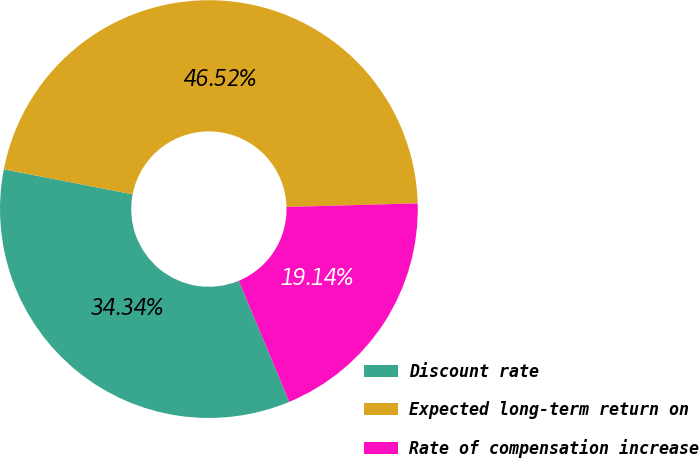Convert chart to OTSL. <chart><loc_0><loc_0><loc_500><loc_500><pie_chart><fcel>Discount rate<fcel>Expected long-term return on<fcel>Rate of compensation increase<nl><fcel>34.34%<fcel>46.52%<fcel>19.14%<nl></chart> 